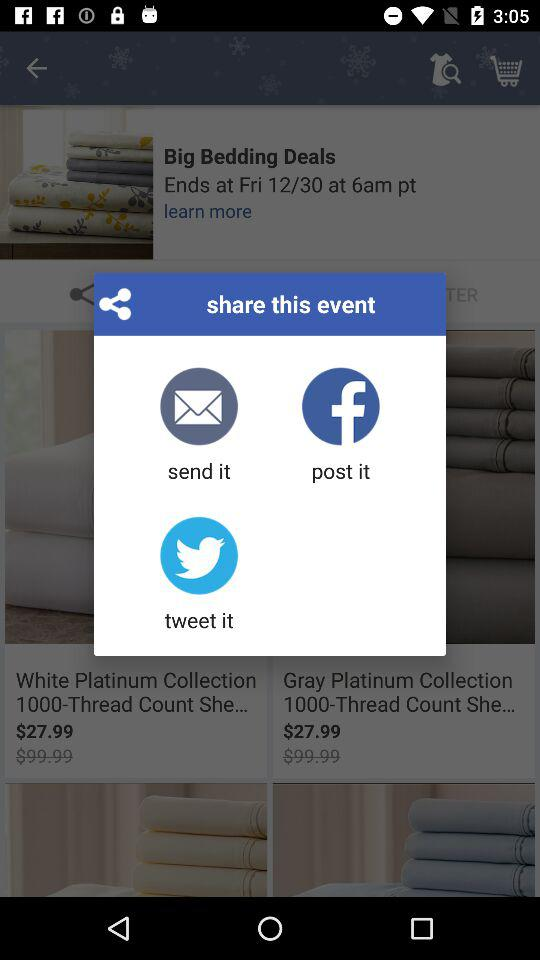What applications do we use for sharing? The applications are "Messaging", "Facebook", and "Twitter". 